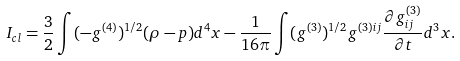<formula> <loc_0><loc_0><loc_500><loc_500>I _ { c l } = \frac { 3 } { 2 } \int ( - g ^ { ( 4 ) } ) ^ { 1 / 2 } ( \rho - p ) d ^ { 4 } x - \frac { 1 } { 1 6 \pi } \int ( g ^ { ( 3 ) } ) ^ { 1 / 2 } g ^ { ( 3 ) i j } \frac { \partial g ^ { ( 3 ) } _ { i j } } { \partial t } d ^ { 3 } x .</formula> 